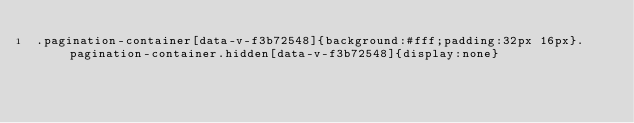<code> <loc_0><loc_0><loc_500><loc_500><_CSS_>.pagination-container[data-v-f3b72548]{background:#fff;padding:32px 16px}.pagination-container.hidden[data-v-f3b72548]{display:none}</code> 